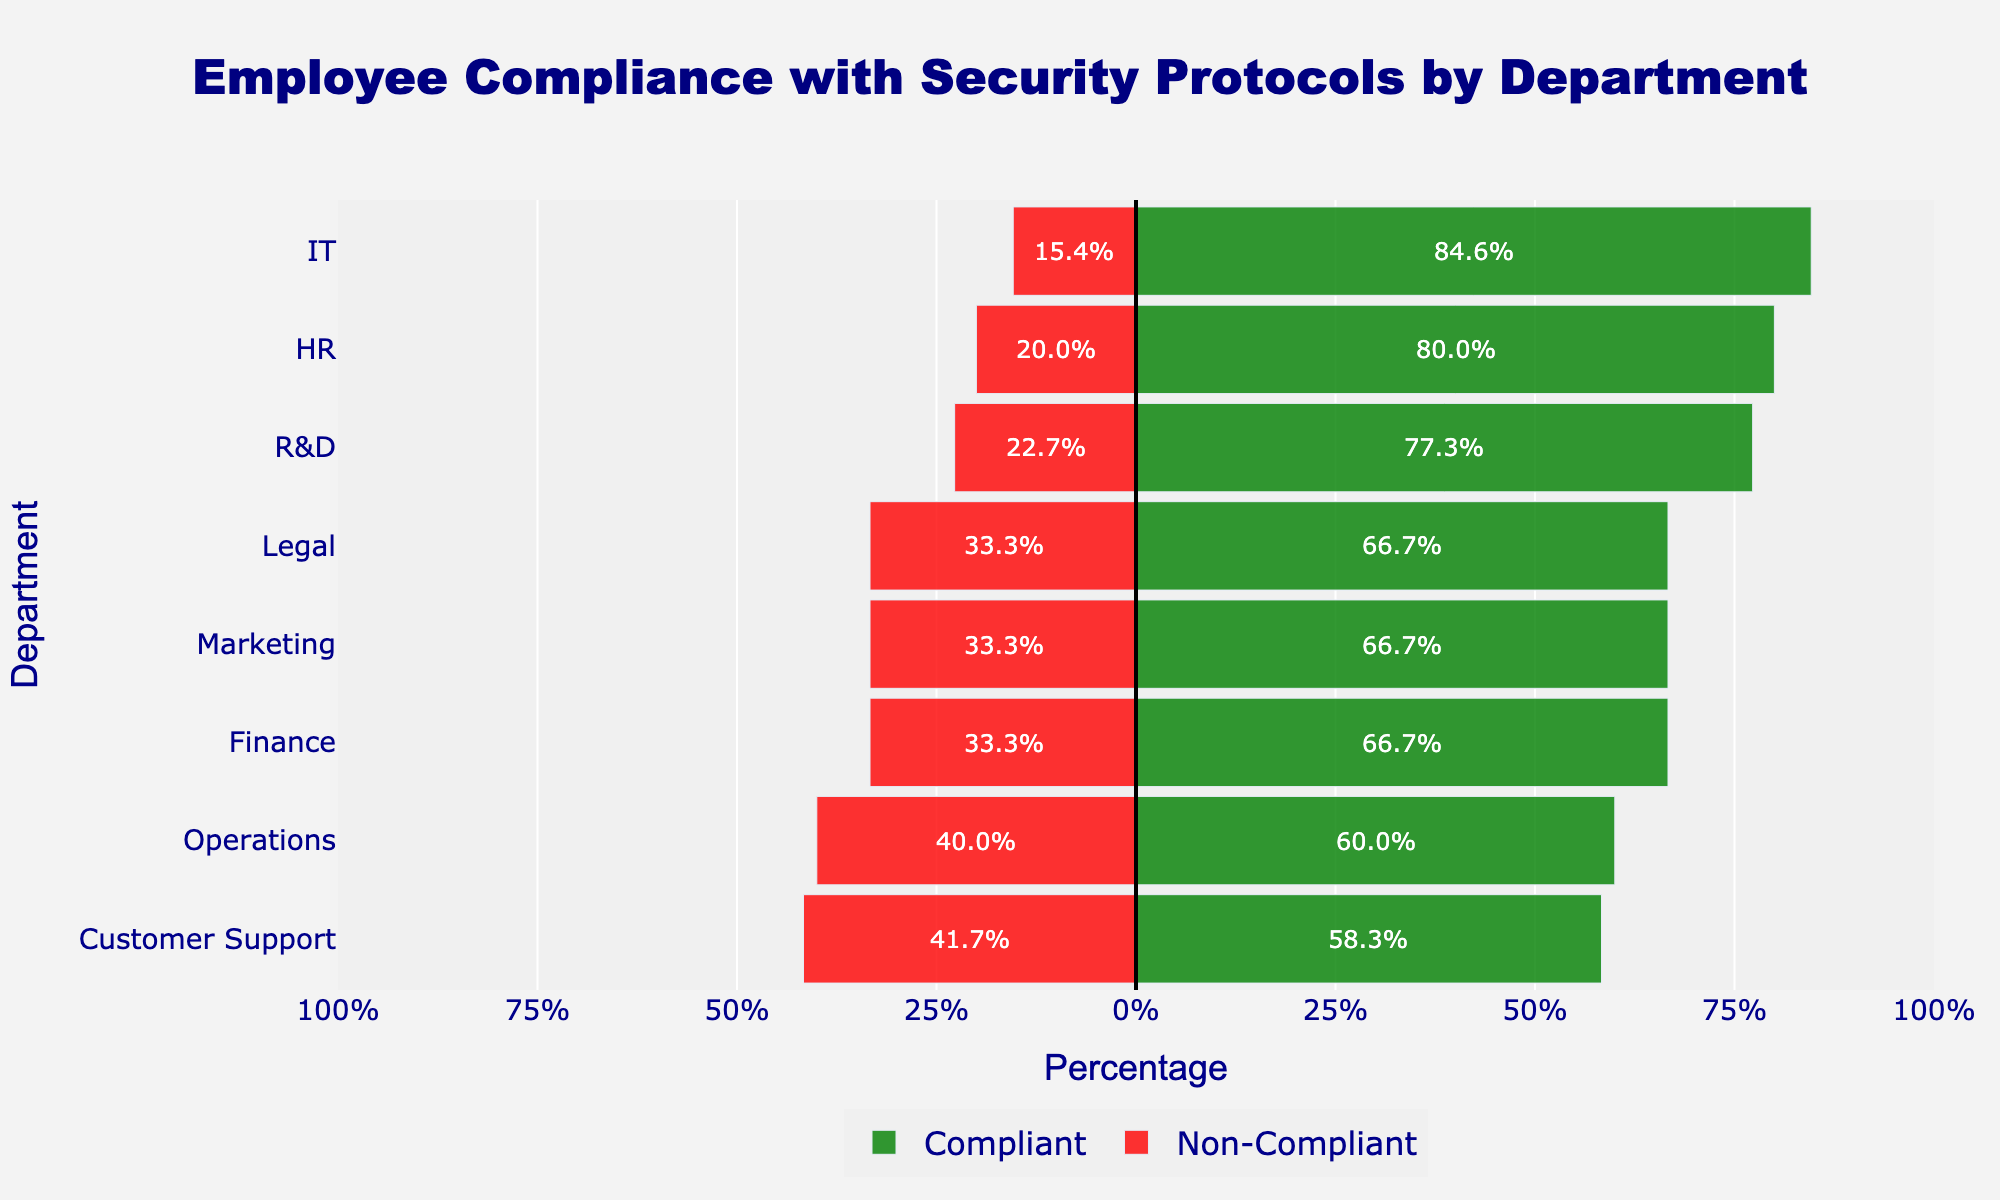Which department has the highest compliance percentage? Looking at the green bars, we find the department with the longest green bar, which is HR.
Answer: HR Which department has the highest non-compliance percentage? Looking at the red bars, we find the department with the longest red bar, which is Operations.
Answer: Operations What is the difference in compliance percentage between IT and Marketing? IT has a compliance percentage of \( \frac{110}{130} \times 100 \approx 84.6\% \). Marketing has a compliance percentage of \( \frac{80}{120} \times 100 \approx 66.7\% \). The difference is \( 84.6\% - 66.7\% = 17.9\% \).
Answer: 17.9% Which department has a higher compliance percentage: Finance or Customer Support? Finance has a compliance percentage of \( \frac{100}{150} \times 100 \approx 66.7\% \). Customer Support has a compliance percentage of \( \frac{70}{120} \times 100 \approx 58.3\% \). Finance has a higher percentage.
Answer: Finance What is the combined compliance percentage for HR and R&D departments? HR has a compliance percentage of \( \frac{120}{150} \times 100 = 80\% \). R&D has a compliance percentage of \( \frac{85}{110} \times 100 \approx 77.3\% \). The combined compliance percentage is \( \frac{120+85}{150+110} \times 100 \approx 78.5\% \).
Answer: 78.5% Which department has a lower non-compliance percentage: Legal or Customer Support? Legal has a non-compliance percentage of \( \frac{30}{90} \times 100 \approx 33.3\% \). Customer Support has a non-compliance percentage of \( \frac{50}{120} \times 100 \approx 41.7\% \). The Legal department has a lower percentage.
Answer: Legal How does the non-compliance percentage of Legal compare to Marketing? Legal has a non-compliance percentage of \( \frac{30}{90} \times 100 \approx 33.3\% \). Marketing has a non-compliance percentage of \( \frac{40}{120} \times 100 \approx 33.3\% \). They are equal.
Answer: Equal Is there any department where the compliance percentage is more than twice the non-compliance percentage? Check each department to see if the compliance percentage is more than twice the non-compliance percentage. IT has compliance \( \approx 84.6\% \) and non-compliance \( \approx 15.4\% \). \( 84.6 \div 15.4 \approx 5.5 \), so IT fits this condition.
Answer: IT 